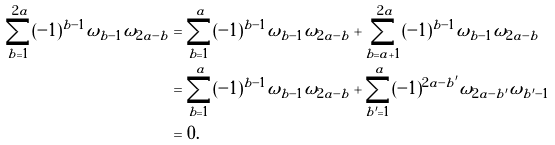Convert formula to latex. <formula><loc_0><loc_0><loc_500><loc_500>\sum _ { b = 1 } ^ { 2 a } ( - 1 ) ^ { b - 1 } \omega _ { b - 1 } \omega _ { 2 a - b } & = \sum _ { b = 1 } ^ { a } ( - 1 ) ^ { b - 1 } \omega _ { b - 1 } \omega _ { 2 a - b } + \sum _ { b = a + 1 } ^ { 2 a } ( - 1 ) ^ { b - 1 } \omega _ { b - 1 } \omega _ { 2 a - b } \\ & = \sum _ { b = 1 } ^ { a } ( - 1 ) ^ { b - 1 } \omega _ { b - 1 } \omega _ { 2 a - b } + \sum _ { b ^ { \prime } = 1 } ^ { a } ( - 1 ) ^ { 2 a - b ^ { \prime } } \omega _ { 2 a - b ^ { \prime } } \omega _ { b ^ { \prime } - 1 } \\ & = 0 .</formula> 